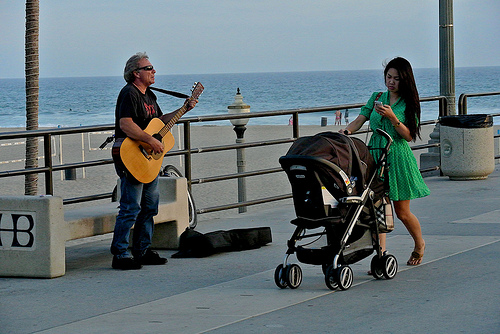<image>
Is the ocean behind the person? Yes. From this viewpoint, the ocean is positioned behind the person, with the person partially or fully occluding the ocean. Is there a bench behind the man? Yes. From this viewpoint, the bench is positioned behind the man, with the man partially or fully occluding the bench. Is there a man behind the sea? No. The man is not behind the sea. From this viewpoint, the man appears to be positioned elsewhere in the scene. Is the case behind the woman? No. The case is not behind the woman. From this viewpoint, the case appears to be positioned elsewhere in the scene. Is the beach on the man? No. The beach is not positioned on the man. They may be near each other, but the beach is not supported by or resting on top of the man. 